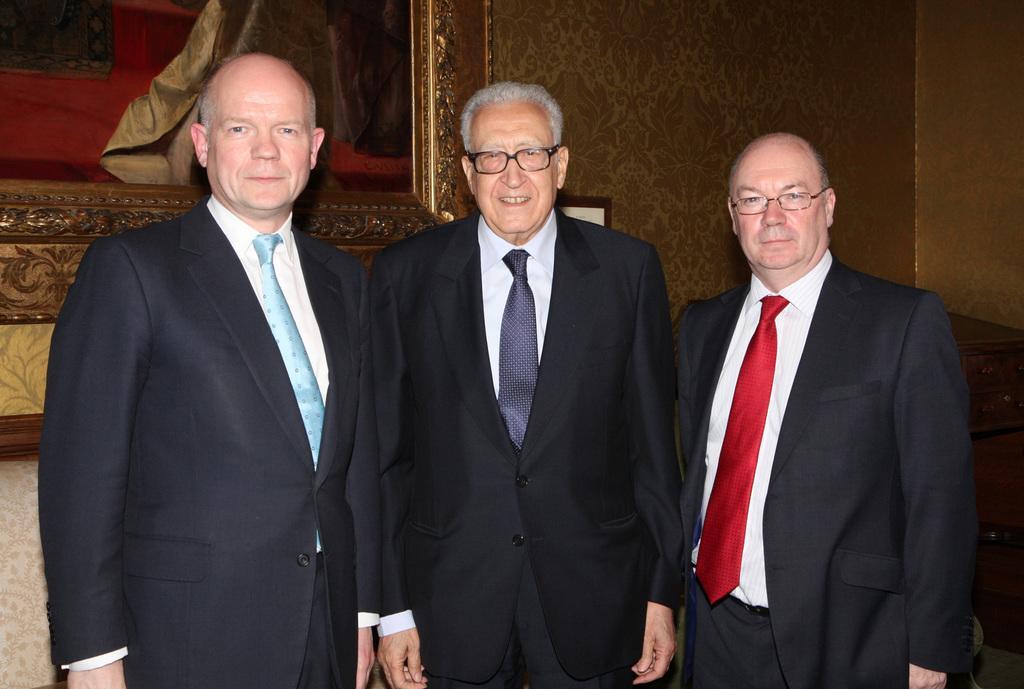Can you describe this image briefly? In this image we can see men standing on the floor. In the background there is a wall hanging to the wall. 